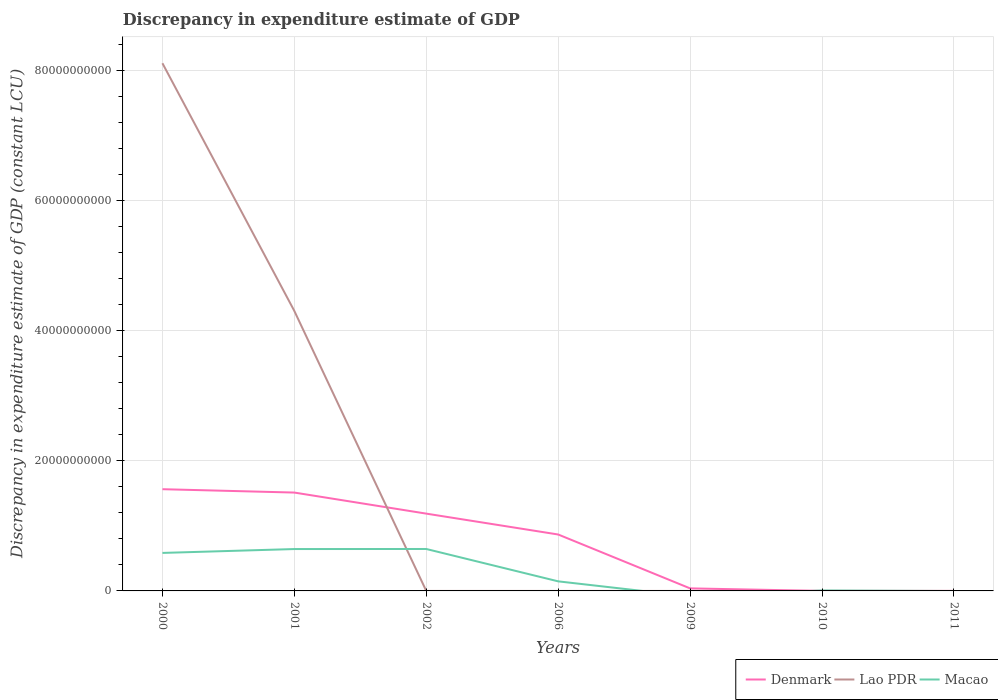How many different coloured lines are there?
Keep it short and to the point. 3. What is the total discrepancy in expenditure estimate of GDP in Lao PDR in the graph?
Your answer should be very brief. 8.12e+1. What is the difference between the highest and the second highest discrepancy in expenditure estimate of GDP in Denmark?
Make the answer very short. 1.56e+1. What is the difference between the highest and the lowest discrepancy in expenditure estimate of GDP in Macao?
Provide a short and direct response. 3. Does the graph contain any zero values?
Your answer should be very brief. Yes. Does the graph contain grids?
Make the answer very short. Yes. How many legend labels are there?
Ensure brevity in your answer.  3. What is the title of the graph?
Keep it short and to the point. Discrepancy in expenditure estimate of GDP. What is the label or title of the Y-axis?
Your response must be concise. Discrepancy in expenditure estimate of GDP (constant LCU). What is the Discrepancy in expenditure estimate of GDP (constant LCU) of Denmark in 2000?
Your answer should be very brief. 1.56e+1. What is the Discrepancy in expenditure estimate of GDP (constant LCU) in Lao PDR in 2000?
Your answer should be very brief. 8.12e+1. What is the Discrepancy in expenditure estimate of GDP (constant LCU) of Macao in 2000?
Provide a succinct answer. 5.85e+09. What is the Discrepancy in expenditure estimate of GDP (constant LCU) in Denmark in 2001?
Ensure brevity in your answer.  1.51e+1. What is the Discrepancy in expenditure estimate of GDP (constant LCU) in Lao PDR in 2001?
Keep it short and to the point. 4.31e+1. What is the Discrepancy in expenditure estimate of GDP (constant LCU) in Macao in 2001?
Offer a terse response. 6.44e+09. What is the Discrepancy in expenditure estimate of GDP (constant LCU) of Denmark in 2002?
Make the answer very short. 1.19e+1. What is the Discrepancy in expenditure estimate of GDP (constant LCU) in Lao PDR in 2002?
Your response must be concise. 7.42e+05. What is the Discrepancy in expenditure estimate of GDP (constant LCU) of Macao in 2002?
Offer a terse response. 6.45e+09. What is the Discrepancy in expenditure estimate of GDP (constant LCU) in Denmark in 2006?
Provide a succinct answer. 8.68e+09. What is the Discrepancy in expenditure estimate of GDP (constant LCU) of Lao PDR in 2006?
Provide a short and direct response. 0. What is the Discrepancy in expenditure estimate of GDP (constant LCU) of Macao in 2006?
Offer a terse response. 1.47e+09. What is the Discrepancy in expenditure estimate of GDP (constant LCU) of Denmark in 2009?
Your response must be concise. 3.91e+08. What is the Discrepancy in expenditure estimate of GDP (constant LCU) of Lao PDR in 2009?
Give a very brief answer. 0. What is the Discrepancy in expenditure estimate of GDP (constant LCU) in Macao in 2009?
Make the answer very short. 0. What is the Discrepancy in expenditure estimate of GDP (constant LCU) in Lao PDR in 2010?
Your answer should be compact. 100. What is the Discrepancy in expenditure estimate of GDP (constant LCU) in Macao in 2010?
Provide a succinct answer. 6.96e+07. What is the Discrepancy in expenditure estimate of GDP (constant LCU) of Lao PDR in 2011?
Your answer should be compact. 100. What is the Discrepancy in expenditure estimate of GDP (constant LCU) of Macao in 2011?
Give a very brief answer. 0. Across all years, what is the maximum Discrepancy in expenditure estimate of GDP (constant LCU) in Denmark?
Make the answer very short. 1.56e+1. Across all years, what is the maximum Discrepancy in expenditure estimate of GDP (constant LCU) in Lao PDR?
Offer a terse response. 8.12e+1. Across all years, what is the maximum Discrepancy in expenditure estimate of GDP (constant LCU) in Macao?
Provide a short and direct response. 6.45e+09. Across all years, what is the minimum Discrepancy in expenditure estimate of GDP (constant LCU) in Lao PDR?
Your answer should be very brief. 0. Across all years, what is the minimum Discrepancy in expenditure estimate of GDP (constant LCU) of Macao?
Offer a very short reply. 0. What is the total Discrepancy in expenditure estimate of GDP (constant LCU) of Denmark in the graph?
Offer a very short reply. 5.17e+1. What is the total Discrepancy in expenditure estimate of GDP (constant LCU) in Lao PDR in the graph?
Provide a succinct answer. 1.24e+11. What is the total Discrepancy in expenditure estimate of GDP (constant LCU) in Macao in the graph?
Offer a terse response. 2.03e+1. What is the difference between the Discrepancy in expenditure estimate of GDP (constant LCU) of Denmark in 2000 and that in 2001?
Ensure brevity in your answer.  5.18e+08. What is the difference between the Discrepancy in expenditure estimate of GDP (constant LCU) of Lao PDR in 2000 and that in 2001?
Make the answer very short. 3.81e+1. What is the difference between the Discrepancy in expenditure estimate of GDP (constant LCU) of Macao in 2000 and that in 2001?
Keep it short and to the point. -5.97e+08. What is the difference between the Discrepancy in expenditure estimate of GDP (constant LCU) in Denmark in 2000 and that in 2002?
Your answer should be compact. 3.76e+09. What is the difference between the Discrepancy in expenditure estimate of GDP (constant LCU) in Lao PDR in 2000 and that in 2002?
Your answer should be compact. 8.12e+1. What is the difference between the Discrepancy in expenditure estimate of GDP (constant LCU) in Macao in 2000 and that in 2002?
Ensure brevity in your answer.  -6.05e+08. What is the difference between the Discrepancy in expenditure estimate of GDP (constant LCU) in Denmark in 2000 and that in 2006?
Provide a short and direct response. 6.97e+09. What is the difference between the Discrepancy in expenditure estimate of GDP (constant LCU) in Macao in 2000 and that in 2006?
Your answer should be very brief. 4.37e+09. What is the difference between the Discrepancy in expenditure estimate of GDP (constant LCU) in Denmark in 2000 and that in 2009?
Provide a short and direct response. 1.53e+1. What is the difference between the Discrepancy in expenditure estimate of GDP (constant LCU) in Denmark in 2000 and that in 2010?
Provide a short and direct response. 1.56e+1. What is the difference between the Discrepancy in expenditure estimate of GDP (constant LCU) in Lao PDR in 2000 and that in 2010?
Offer a terse response. 8.12e+1. What is the difference between the Discrepancy in expenditure estimate of GDP (constant LCU) of Macao in 2000 and that in 2010?
Provide a short and direct response. 5.78e+09. What is the difference between the Discrepancy in expenditure estimate of GDP (constant LCU) of Lao PDR in 2000 and that in 2011?
Ensure brevity in your answer.  8.12e+1. What is the difference between the Discrepancy in expenditure estimate of GDP (constant LCU) of Denmark in 2001 and that in 2002?
Offer a very short reply. 3.24e+09. What is the difference between the Discrepancy in expenditure estimate of GDP (constant LCU) of Lao PDR in 2001 and that in 2002?
Offer a terse response. 4.31e+1. What is the difference between the Discrepancy in expenditure estimate of GDP (constant LCU) in Macao in 2001 and that in 2002?
Your response must be concise. -7.80e+06. What is the difference between the Discrepancy in expenditure estimate of GDP (constant LCU) of Denmark in 2001 and that in 2006?
Provide a succinct answer. 6.45e+09. What is the difference between the Discrepancy in expenditure estimate of GDP (constant LCU) in Macao in 2001 and that in 2006?
Your answer should be very brief. 4.97e+09. What is the difference between the Discrepancy in expenditure estimate of GDP (constant LCU) in Denmark in 2001 and that in 2009?
Provide a short and direct response. 1.47e+1. What is the difference between the Discrepancy in expenditure estimate of GDP (constant LCU) of Denmark in 2001 and that in 2010?
Provide a short and direct response. 1.51e+1. What is the difference between the Discrepancy in expenditure estimate of GDP (constant LCU) of Lao PDR in 2001 and that in 2010?
Ensure brevity in your answer.  4.31e+1. What is the difference between the Discrepancy in expenditure estimate of GDP (constant LCU) of Macao in 2001 and that in 2010?
Provide a short and direct response. 6.37e+09. What is the difference between the Discrepancy in expenditure estimate of GDP (constant LCU) of Lao PDR in 2001 and that in 2011?
Offer a very short reply. 4.31e+1. What is the difference between the Discrepancy in expenditure estimate of GDP (constant LCU) of Denmark in 2002 and that in 2006?
Your answer should be compact. 3.21e+09. What is the difference between the Discrepancy in expenditure estimate of GDP (constant LCU) in Macao in 2002 and that in 2006?
Make the answer very short. 4.98e+09. What is the difference between the Discrepancy in expenditure estimate of GDP (constant LCU) in Denmark in 2002 and that in 2009?
Give a very brief answer. 1.15e+1. What is the difference between the Discrepancy in expenditure estimate of GDP (constant LCU) in Denmark in 2002 and that in 2010?
Provide a short and direct response. 1.19e+1. What is the difference between the Discrepancy in expenditure estimate of GDP (constant LCU) in Lao PDR in 2002 and that in 2010?
Give a very brief answer. 7.42e+05. What is the difference between the Discrepancy in expenditure estimate of GDP (constant LCU) of Macao in 2002 and that in 2010?
Make the answer very short. 6.38e+09. What is the difference between the Discrepancy in expenditure estimate of GDP (constant LCU) of Lao PDR in 2002 and that in 2011?
Give a very brief answer. 7.42e+05. What is the difference between the Discrepancy in expenditure estimate of GDP (constant LCU) of Denmark in 2006 and that in 2009?
Your response must be concise. 8.29e+09. What is the difference between the Discrepancy in expenditure estimate of GDP (constant LCU) of Denmark in 2006 and that in 2010?
Make the answer very short. 8.68e+09. What is the difference between the Discrepancy in expenditure estimate of GDP (constant LCU) of Macao in 2006 and that in 2010?
Your answer should be compact. 1.40e+09. What is the difference between the Discrepancy in expenditure estimate of GDP (constant LCU) in Denmark in 2009 and that in 2010?
Your answer should be very brief. 3.90e+08. What is the difference between the Discrepancy in expenditure estimate of GDP (constant LCU) of Denmark in 2000 and the Discrepancy in expenditure estimate of GDP (constant LCU) of Lao PDR in 2001?
Offer a very short reply. -2.74e+1. What is the difference between the Discrepancy in expenditure estimate of GDP (constant LCU) of Denmark in 2000 and the Discrepancy in expenditure estimate of GDP (constant LCU) of Macao in 2001?
Give a very brief answer. 9.21e+09. What is the difference between the Discrepancy in expenditure estimate of GDP (constant LCU) in Lao PDR in 2000 and the Discrepancy in expenditure estimate of GDP (constant LCU) in Macao in 2001?
Your answer should be compact. 7.47e+1. What is the difference between the Discrepancy in expenditure estimate of GDP (constant LCU) in Denmark in 2000 and the Discrepancy in expenditure estimate of GDP (constant LCU) in Lao PDR in 2002?
Keep it short and to the point. 1.56e+1. What is the difference between the Discrepancy in expenditure estimate of GDP (constant LCU) in Denmark in 2000 and the Discrepancy in expenditure estimate of GDP (constant LCU) in Macao in 2002?
Provide a short and direct response. 9.20e+09. What is the difference between the Discrepancy in expenditure estimate of GDP (constant LCU) in Lao PDR in 2000 and the Discrepancy in expenditure estimate of GDP (constant LCU) in Macao in 2002?
Ensure brevity in your answer.  7.47e+1. What is the difference between the Discrepancy in expenditure estimate of GDP (constant LCU) in Denmark in 2000 and the Discrepancy in expenditure estimate of GDP (constant LCU) in Macao in 2006?
Provide a short and direct response. 1.42e+1. What is the difference between the Discrepancy in expenditure estimate of GDP (constant LCU) in Lao PDR in 2000 and the Discrepancy in expenditure estimate of GDP (constant LCU) in Macao in 2006?
Provide a succinct answer. 7.97e+1. What is the difference between the Discrepancy in expenditure estimate of GDP (constant LCU) in Denmark in 2000 and the Discrepancy in expenditure estimate of GDP (constant LCU) in Lao PDR in 2010?
Give a very brief answer. 1.56e+1. What is the difference between the Discrepancy in expenditure estimate of GDP (constant LCU) in Denmark in 2000 and the Discrepancy in expenditure estimate of GDP (constant LCU) in Macao in 2010?
Your answer should be compact. 1.56e+1. What is the difference between the Discrepancy in expenditure estimate of GDP (constant LCU) in Lao PDR in 2000 and the Discrepancy in expenditure estimate of GDP (constant LCU) in Macao in 2010?
Provide a succinct answer. 8.11e+1. What is the difference between the Discrepancy in expenditure estimate of GDP (constant LCU) of Denmark in 2000 and the Discrepancy in expenditure estimate of GDP (constant LCU) of Lao PDR in 2011?
Provide a short and direct response. 1.56e+1. What is the difference between the Discrepancy in expenditure estimate of GDP (constant LCU) in Denmark in 2001 and the Discrepancy in expenditure estimate of GDP (constant LCU) in Lao PDR in 2002?
Provide a succinct answer. 1.51e+1. What is the difference between the Discrepancy in expenditure estimate of GDP (constant LCU) of Denmark in 2001 and the Discrepancy in expenditure estimate of GDP (constant LCU) of Macao in 2002?
Make the answer very short. 8.68e+09. What is the difference between the Discrepancy in expenditure estimate of GDP (constant LCU) in Lao PDR in 2001 and the Discrepancy in expenditure estimate of GDP (constant LCU) in Macao in 2002?
Provide a short and direct response. 3.66e+1. What is the difference between the Discrepancy in expenditure estimate of GDP (constant LCU) in Denmark in 2001 and the Discrepancy in expenditure estimate of GDP (constant LCU) in Macao in 2006?
Offer a very short reply. 1.37e+1. What is the difference between the Discrepancy in expenditure estimate of GDP (constant LCU) of Lao PDR in 2001 and the Discrepancy in expenditure estimate of GDP (constant LCU) of Macao in 2006?
Your response must be concise. 4.16e+1. What is the difference between the Discrepancy in expenditure estimate of GDP (constant LCU) in Denmark in 2001 and the Discrepancy in expenditure estimate of GDP (constant LCU) in Lao PDR in 2010?
Offer a very short reply. 1.51e+1. What is the difference between the Discrepancy in expenditure estimate of GDP (constant LCU) of Denmark in 2001 and the Discrepancy in expenditure estimate of GDP (constant LCU) of Macao in 2010?
Make the answer very short. 1.51e+1. What is the difference between the Discrepancy in expenditure estimate of GDP (constant LCU) in Lao PDR in 2001 and the Discrepancy in expenditure estimate of GDP (constant LCU) in Macao in 2010?
Your answer should be compact. 4.30e+1. What is the difference between the Discrepancy in expenditure estimate of GDP (constant LCU) of Denmark in 2001 and the Discrepancy in expenditure estimate of GDP (constant LCU) of Lao PDR in 2011?
Provide a succinct answer. 1.51e+1. What is the difference between the Discrepancy in expenditure estimate of GDP (constant LCU) in Denmark in 2002 and the Discrepancy in expenditure estimate of GDP (constant LCU) in Macao in 2006?
Give a very brief answer. 1.04e+1. What is the difference between the Discrepancy in expenditure estimate of GDP (constant LCU) in Lao PDR in 2002 and the Discrepancy in expenditure estimate of GDP (constant LCU) in Macao in 2006?
Your answer should be very brief. -1.47e+09. What is the difference between the Discrepancy in expenditure estimate of GDP (constant LCU) in Denmark in 2002 and the Discrepancy in expenditure estimate of GDP (constant LCU) in Lao PDR in 2010?
Give a very brief answer. 1.19e+1. What is the difference between the Discrepancy in expenditure estimate of GDP (constant LCU) in Denmark in 2002 and the Discrepancy in expenditure estimate of GDP (constant LCU) in Macao in 2010?
Offer a very short reply. 1.18e+1. What is the difference between the Discrepancy in expenditure estimate of GDP (constant LCU) of Lao PDR in 2002 and the Discrepancy in expenditure estimate of GDP (constant LCU) of Macao in 2010?
Offer a very short reply. -6.89e+07. What is the difference between the Discrepancy in expenditure estimate of GDP (constant LCU) of Denmark in 2002 and the Discrepancy in expenditure estimate of GDP (constant LCU) of Lao PDR in 2011?
Provide a succinct answer. 1.19e+1. What is the difference between the Discrepancy in expenditure estimate of GDP (constant LCU) of Denmark in 2006 and the Discrepancy in expenditure estimate of GDP (constant LCU) of Lao PDR in 2010?
Provide a short and direct response. 8.68e+09. What is the difference between the Discrepancy in expenditure estimate of GDP (constant LCU) in Denmark in 2006 and the Discrepancy in expenditure estimate of GDP (constant LCU) in Macao in 2010?
Provide a short and direct response. 8.61e+09. What is the difference between the Discrepancy in expenditure estimate of GDP (constant LCU) of Denmark in 2006 and the Discrepancy in expenditure estimate of GDP (constant LCU) of Lao PDR in 2011?
Ensure brevity in your answer.  8.68e+09. What is the difference between the Discrepancy in expenditure estimate of GDP (constant LCU) of Denmark in 2009 and the Discrepancy in expenditure estimate of GDP (constant LCU) of Lao PDR in 2010?
Give a very brief answer. 3.91e+08. What is the difference between the Discrepancy in expenditure estimate of GDP (constant LCU) of Denmark in 2009 and the Discrepancy in expenditure estimate of GDP (constant LCU) of Macao in 2010?
Keep it short and to the point. 3.21e+08. What is the difference between the Discrepancy in expenditure estimate of GDP (constant LCU) of Denmark in 2009 and the Discrepancy in expenditure estimate of GDP (constant LCU) of Lao PDR in 2011?
Offer a terse response. 3.91e+08. What is the difference between the Discrepancy in expenditure estimate of GDP (constant LCU) of Denmark in 2010 and the Discrepancy in expenditure estimate of GDP (constant LCU) of Lao PDR in 2011?
Offer a very short reply. 1.00e+06. What is the average Discrepancy in expenditure estimate of GDP (constant LCU) in Denmark per year?
Make the answer very short. 7.39e+09. What is the average Discrepancy in expenditure estimate of GDP (constant LCU) of Lao PDR per year?
Your answer should be very brief. 1.77e+1. What is the average Discrepancy in expenditure estimate of GDP (constant LCU) of Macao per year?
Your answer should be compact. 2.90e+09. In the year 2000, what is the difference between the Discrepancy in expenditure estimate of GDP (constant LCU) in Denmark and Discrepancy in expenditure estimate of GDP (constant LCU) in Lao PDR?
Offer a terse response. -6.55e+1. In the year 2000, what is the difference between the Discrepancy in expenditure estimate of GDP (constant LCU) in Denmark and Discrepancy in expenditure estimate of GDP (constant LCU) in Macao?
Give a very brief answer. 9.80e+09. In the year 2000, what is the difference between the Discrepancy in expenditure estimate of GDP (constant LCU) of Lao PDR and Discrepancy in expenditure estimate of GDP (constant LCU) of Macao?
Keep it short and to the point. 7.53e+1. In the year 2001, what is the difference between the Discrepancy in expenditure estimate of GDP (constant LCU) of Denmark and Discrepancy in expenditure estimate of GDP (constant LCU) of Lao PDR?
Offer a terse response. -2.79e+1. In the year 2001, what is the difference between the Discrepancy in expenditure estimate of GDP (constant LCU) in Denmark and Discrepancy in expenditure estimate of GDP (constant LCU) in Macao?
Your response must be concise. 8.69e+09. In the year 2001, what is the difference between the Discrepancy in expenditure estimate of GDP (constant LCU) in Lao PDR and Discrepancy in expenditure estimate of GDP (constant LCU) in Macao?
Give a very brief answer. 3.66e+1. In the year 2002, what is the difference between the Discrepancy in expenditure estimate of GDP (constant LCU) in Denmark and Discrepancy in expenditure estimate of GDP (constant LCU) in Lao PDR?
Provide a succinct answer. 1.19e+1. In the year 2002, what is the difference between the Discrepancy in expenditure estimate of GDP (constant LCU) in Denmark and Discrepancy in expenditure estimate of GDP (constant LCU) in Macao?
Your response must be concise. 5.44e+09. In the year 2002, what is the difference between the Discrepancy in expenditure estimate of GDP (constant LCU) in Lao PDR and Discrepancy in expenditure estimate of GDP (constant LCU) in Macao?
Offer a very short reply. -6.45e+09. In the year 2006, what is the difference between the Discrepancy in expenditure estimate of GDP (constant LCU) in Denmark and Discrepancy in expenditure estimate of GDP (constant LCU) in Macao?
Offer a very short reply. 7.21e+09. In the year 2010, what is the difference between the Discrepancy in expenditure estimate of GDP (constant LCU) in Denmark and Discrepancy in expenditure estimate of GDP (constant LCU) in Lao PDR?
Ensure brevity in your answer.  1.00e+06. In the year 2010, what is the difference between the Discrepancy in expenditure estimate of GDP (constant LCU) of Denmark and Discrepancy in expenditure estimate of GDP (constant LCU) of Macao?
Your answer should be compact. -6.86e+07. In the year 2010, what is the difference between the Discrepancy in expenditure estimate of GDP (constant LCU) of Lao PDR and Discrepancy in expenditure estimate of GDP (constant LCU) of Macao?
Offer a terse response. -6.96e+07. What is the ratio of the Discrepancy in expenditure estimate of GDP (constant LCU) of Denmark in 2000 to that in 2001?
Offer a very short reply. 1.03. What is the ratio of the Discrepancy in expenditure estimate of GDP (constant LCU) of Lao PDR in 2000 to that in 2001?
Provide a succinct answer. 1.89. What is the ratio of the Discrepancy in expenditure estimate of GDP (constant LCU) of Macao in 2000 to that in 2001?
Your response must be concise. 0.91. What is the ratio of the Discrepancy in expenditure estimate of GDP (constant LCU) in Denmark in 2000 to that in 2002?
Make the answer very short. 1.32. What is the ratio of the Discrepancy in expenditure estimate of GDP (constant LCU) in Lao PDR in 2000 to that in 2002?
Make the answer very short. 1.09e+05. What is the ratio of the Discrepancy in expenditure estimate of GDP (constant LCU) in Macao in 2000 to that in 2002?
Your answer should be very brief. 0.91. What is the ratio of the Discrepancy in expenditure estimate of GDP (constant LCU) of Denmark in 2000 to that in 2006?
Your answer should be very brief. 1.8. What is the ratio of the Discrepancy in expenditure estimate of GDP (constant LCU) in Macao in 2000 to that in 2006?
Give a very brief answer. 3.97. What is the ratio of the Discrepancy in expenditure estimate of GDP (constant LCU) of Denmark in 2000 to that in 2009?
Offer a very short reply. 40.02. What is the ratio of the Discrepancy in expenditure estimate of GDP (constant LCU) in Denmark in 2000 to that in 2010?
Provide a succinct answer. 1.56e+04. What is the ratio of the Discrepancy in expenditure estimate of GDP (constant LCU) of Lao PDR in 2000 to that in 2010?
Make the answer very short. 8.12e+08. What is the ratio of the Discrepancy in expenditure estimate of GDP (constant LCU) in Macao in 2000 to that in 2010?
Keep it short and to the point. 83.99. What is the ratio of the Discrepancy in expenditure estimate of GDP (constant LCU) of Lao PDR in 2000 to that in 2011?
Give a very brief answer. 8.12e+08. What is the ratio of the Discrepancy in expenditure estimate of GDP (constant LCU) in Denmark in 2001 to that in 2002?
Your answer should be very brief. 1.27. What is the ratio of the Discrepancy in expenditure estimate of GDP (constant LCU) in Lao PDR in 2001 to that in 2002?
Your answer should be very brief. 5.81e+04. What is the ratio of the Discrepancy in expenditure estimate of GDP (constant LCU) of Denmark in 2001 to that in 2006?
Provide a succinct answer. 1.74. What is the ratio of the Discrepancy in expenditure estimate of GDP (constant LCU) in Macao in 2001 to that in 2006?
Keep it short and to the point. 4.37. What is the ratio of the Discrepancy in expenditure estimate of GDP (constant LCU) in Denmark in 2001 to that in 2009?
Provide a short and direct response. 38.7. What is the ratio of the Discrepancy in expenditure estimate of GDP (constant LCU) in Denmark in 2001 to that in 2010?
Offer a terse response. 1.51e+04. What is the ratio of the Discrepancy in expenditure estimate of GDP (constant LCU) in Lao PDR in 2001 to that in 2010?
Ensure brevity in your answer.  4.31e+08. What is the ratio of the Discrepancy in expenditure estimate of GDP (constant LCU) in Macao in 2001 to that in 2010?
Your answer should be compact. 92.56. What is the ratio of the Discrepancy in expenditure estimate of GDP (constant LCU) in Lao PDR in 2001 to that in 2011?
Ensure brevity in your answer.  4.31e+08. What is the ratio of the Discrepancy in expenditure estimate of GDP (constant LCU) in Denmark in 2002 to that in 2006?
Offer a very short reply. 1.37. What is the ratio of the Discrepancy in expenditure estimate of GDP (constant LCU) in Macao in 2002 to that in 2006?
Offer a very short reply. 4.38. What is the ratio of the Discrepancy in expenditure estimate of GDP (constant LCU) in Denmark in 2002 to that in 2009?
Provide a short and direct response. 30.41. What is the ratio of the Discrepancy in expenditure estimate of GDP (constant LCU) of Denmark in 2002 to that in 2010?
Keep it short and to the point. 1.19e+04. What is the ratio of the Discrepancy in expenditure estimate of GDP (constant LCU) of Lao PDR in 2002 to that in 2010?
Your answer should be very brief. 7418. What is the ratio of the Discrepancy in expenditure estimate of GDP (constant LCU) in Macao in 2002 to that in 2010?
Ensure brevity in your answer.  92.68. What is the ratio of the Discrepancy in expenditure estimate of GDP (constant LCU) of Lao PDR in 2002 to that in 2011?
Offer a terse response. 7418. What is the ratio of the Discrepancy in expenditure estimate of GDP (constant LCU) of Denmark in 2006 to that in 2009?
Your answer should be very brief. 22.2. What is the ratio of the Discrepancy in expenditure estimate of GDP (constant LCU) in Denmark in 2006 to that in 2010?
Your response must be concise. 8679. What is the ratio of the Discrepancy in expenditure estimate of GDP (constant LCU) of Macao in 2006 to that in 2010?
Offer a very short reply. 21.16. What is the ratio of the Discrepancy in expenditure estimate of GDP (constant LCU) in Denmark in 2009 to that in 2010?
Give a very brief answer. 391. What is the ratio of the Discrepancy in expenditure estimate of GDP (constant LCU) of Lao PDR in 2010 to that in 2011?
Your response must be concise. 1. What is the difference between the highest and the second highest Discrepancy in expenditure estimate of GDP (constant LCU) of Denmark?
Give a very brief answer. 5.18e+08. What is the difference between the highest and the second highest Discrepancy in expenditure estimate of GDP (constant LCU) in Lao PDR?
Your response must be concise. 3.81e+1. What is the difference between the highest and the second highest Discrepancy in expenditure estimate of GDP (constant LCU) of Macao?
Provide a succinct answer. 7.80e+06. What is the difference between the highest and the lowest Discrepancy in expenditure estimate of GDP (constant LCU) in Denmark?
Provide a succinct answer. 1.56e+1. What is the difference between the highest and the lowest Discrepancy in expenditure estimate of GDP (constant LCU) of Lao PDR?
Provide a succinct answer. 8.12e+1. What is the difference between the highest and the lowest Discrepancy in expenditure estimate of GDP (constant LCU) of Macao?
Your response must be concise. 6.45e+09. 